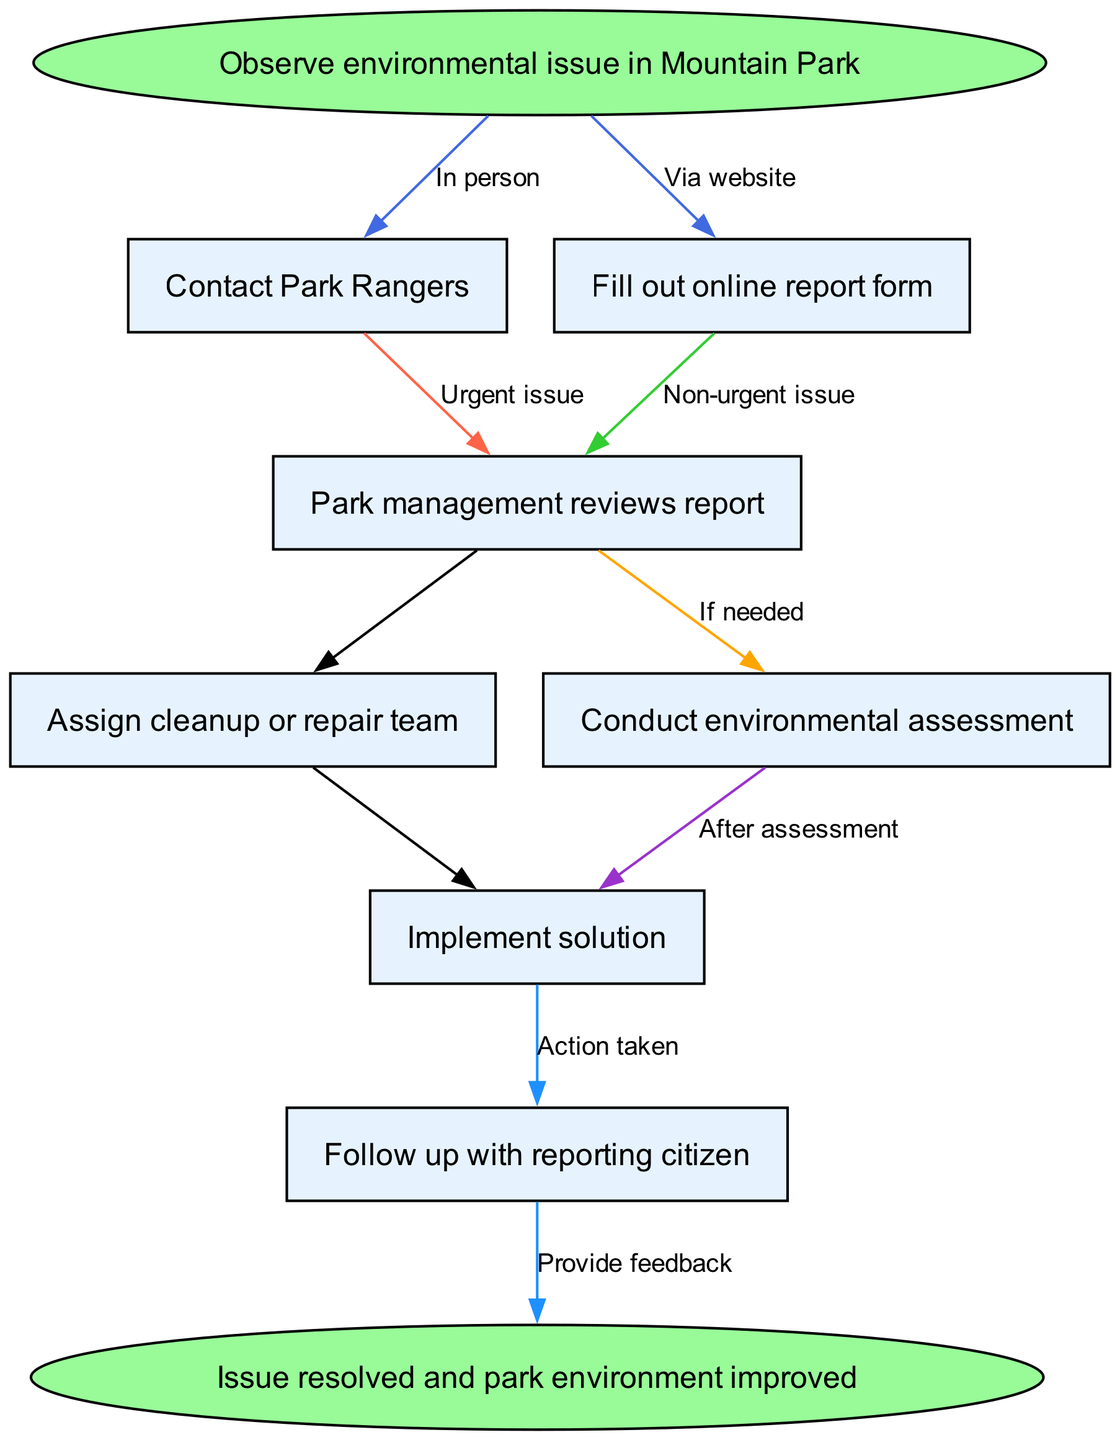What is the starting point of the flowchart? The flowchart starts with the node "Observe environmental issue in Mountain Park." This is the initial action that triggers the entire process.
Answer: Observe environmental issue in Mountain Park How many nodes are in the diagram? The diagram contains a total of 8 nodes (including the start and end nodes). Counting all nodes listed and the start and end, we arrive at this total.
Answer: 8 What action is taken for urgent issues? For urgent issues, the next action is "Contact Park Rangers." This indicates that immediate communication with the park rangers is necessary for urgent situations.
Answer: Contact Park Rangers What happens after park management reviews the report? After the report is reviewed, the park management either "Assigns cleanup or repair team" or "Conducts environmental assessment" if needed. This shows that decisions are made based on the review's outcome.
Answer: Assign cleanup or repair team / Conduct environmental assessment What is the purpose of following up with the reporting citizen? The purpose of following up is to provide feedback about the "Action taken." This ensures that the citizen is informed about the resolution of their concern and the actions taken in response.
Answer: Provide feedback If a report is filled out online, what happens next? If the report is filled out online, the next step is "Park management reviews report" because this is the process that takes place after the online submission.
Answer: Park management reviews report What determines whether an environmental assessment will be conducted? An environmental assessment will be conducted if it is "If needed," which suggests that the decision to perform the assessment relies on the evaluation performed by park management after reviewing the report.
Answer: If needed What signifies the end of the process? The process concludes with the node "Issue resolved and park environment improved," indicating that the ultimate goal is to ensure that any environmental issues are addressed successfully.
Answer: Issue resolved and park environment improved 